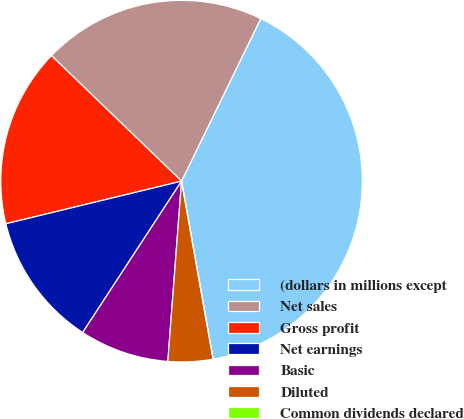<chart> <loc_0><loc_0><loc_500><loc_500><pie_chart><fcel>(dollars in millions except<fcel>Net sales<fcel>Gross profit<fcel>Net earnings<fcel>Basic<fcel>Diluted<fcel>Common dividends declared<nl><fcel>39.99%<fcel>20.0%<fcel>16.0%<fcel>12.0%<fcel>8.0%<fcel>4.0%<fcel>0.0%<nl></chart> 